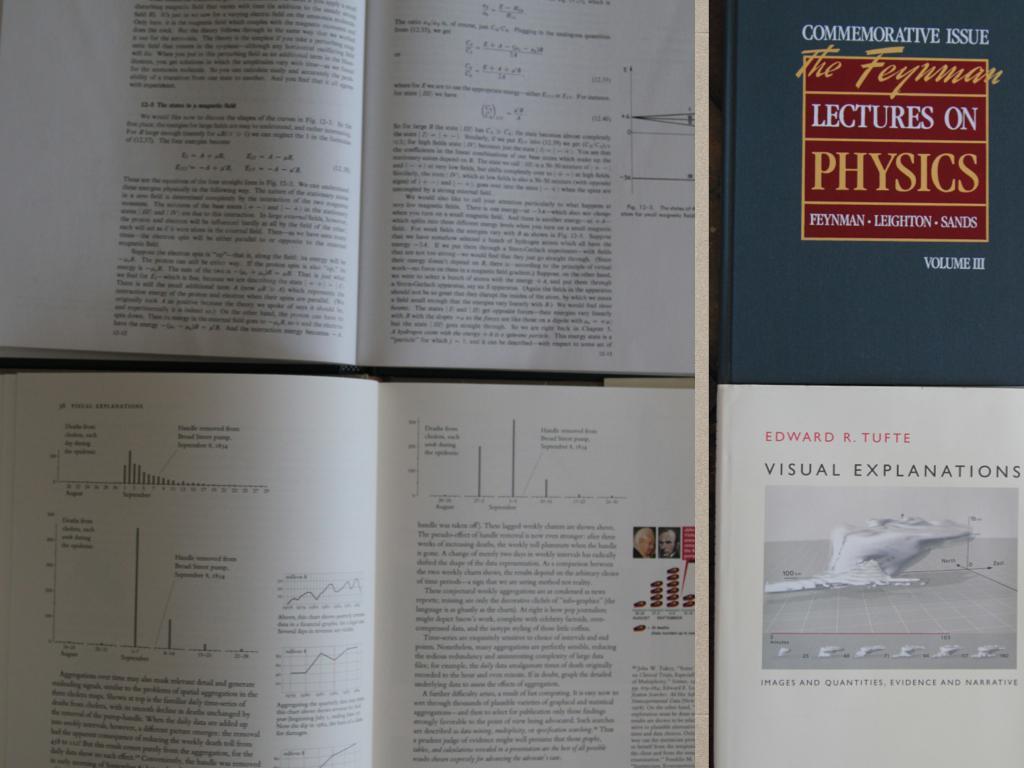Please provide a concise description of this image. In this image I can see few books and something written on it. 